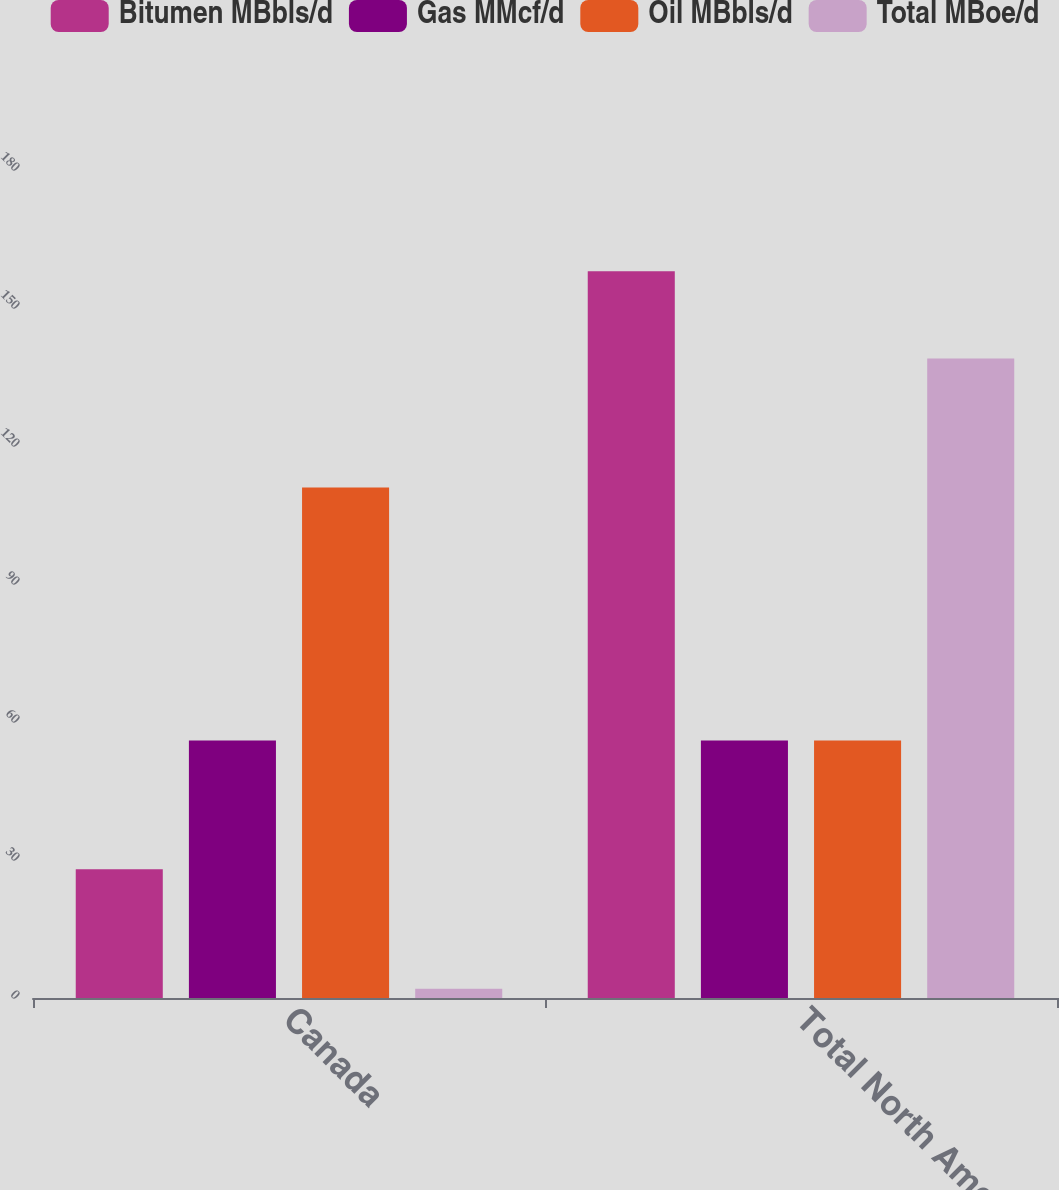Convert chart to OTSL. <chart><loc_0><loc_0><loc_500><loc_500><stacked_bar_chart><ecel><fcel>Canada<fcel>Total North America<nl><fcel>Bitumen MBbls/d<fcel>28<fcel>158<nl><fcel>Gas MMcf/d<fcel>56<fcel>56<nl><fcel>Oil MBbls/d<fcel>111<fcel>56<nl><fcel>Total MBoe/d<fcel>2<fcel>139<nl></chart> 